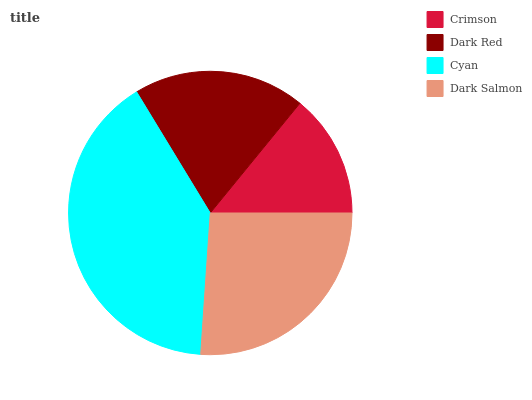Is Crimson the minimum?
Answer yes or no. Yes. Is Cyan the maximum?
Answer yes or no. Yes. Is Dark Red the minimum?
Answer yes or no. No. Is Dark Red the maximum?
Answer yes or no. No. Is Dark Red greater than Crimson?
Answer yes or no. Yes. Is Crimson less than Dark Red?
Answer yes or no. Yes. Is Crimson greater than Dark Red?
Answer yes or no. No. Is Dark Red less than Crimson?
Answer yes or no. No. Is Dark Salmon the high median?
Answer yes or no. Yes. Is Dark Red the low median?
Answer yes or no. Yes. Is Crimson the high median?
Answer yes or no. No. Is Dark Salmon the low median?
Answer yes or no. No. 